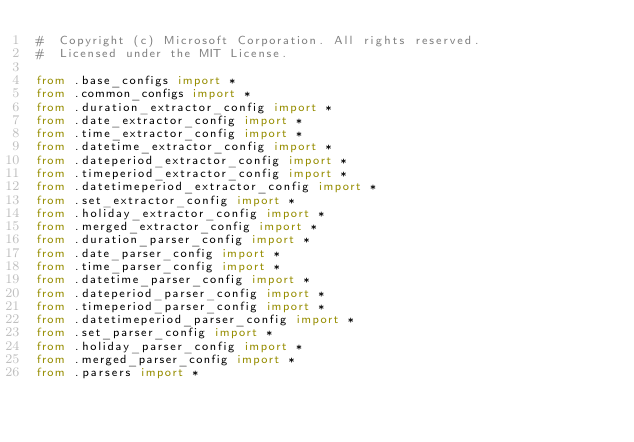<code> <loc_0><loc_0><loc_500><loc_500><_Python_>#  Copyright (c) Microsoft Corporation. All rights reserved.
#  Licensed under the MIT License.

from .base_configs import *
from .common_configs import *
from .duration_extractor_config import *
from .date_extractor_config import *
from .time_extractor_config import *
from .datetime_extractor_config import *
from .dateperiod_extractor_config import *
from .timeperiod_extractor_config import *
from .datetimeperiod_extractor_config import *
from .set_extractor_config import *
from .holiday_extractor_config import *
from .merged_extractor_config import *
from .duration_parser_config import *
from .date_parser_config import *
from .time_parser_config import *
from .datetime_parser_config import *
from .dateperiod_parser_config import *
from .timeperiod_parser_config import *
from .datetimeperiod_parser_config import *
from .set_parser_config import *
from .holiday_parser_config import *
from .merged_parser_config import *
from .parsers import *
</code> 